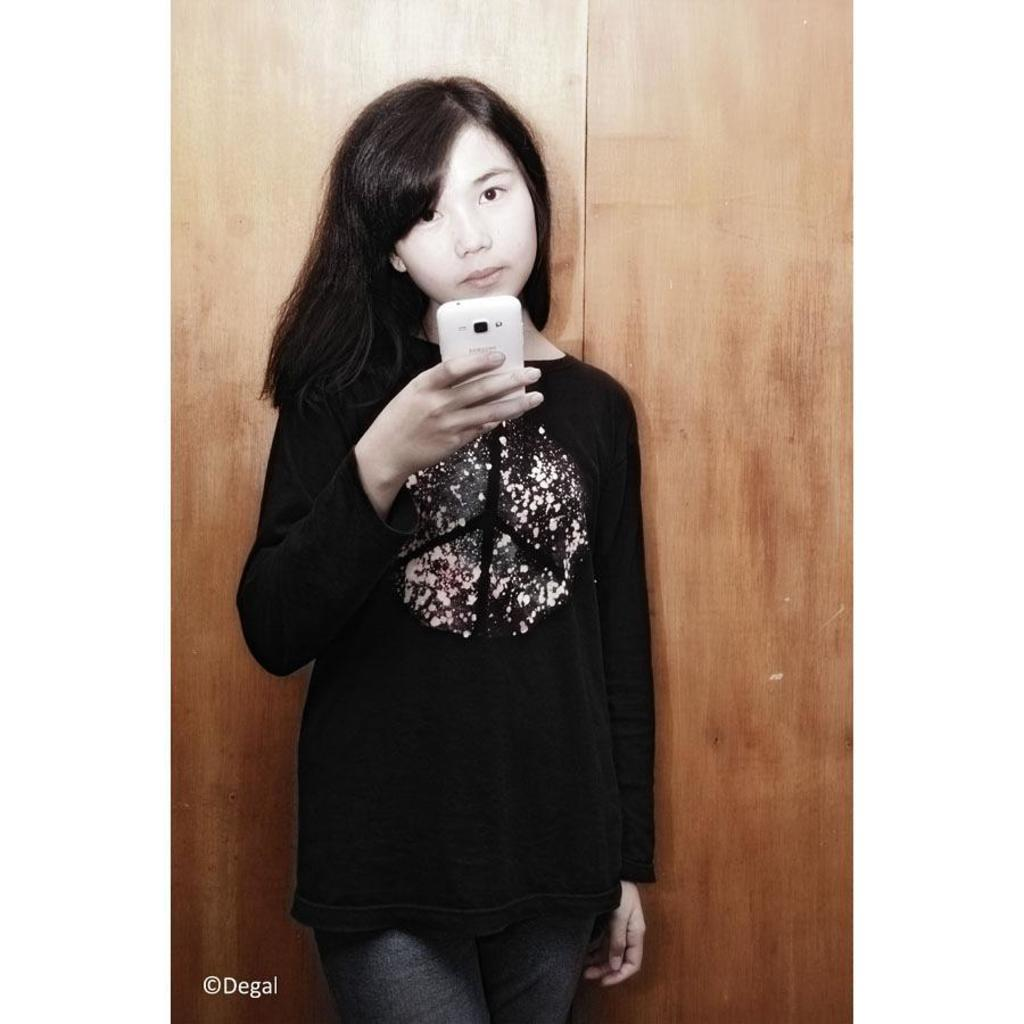Who is the main subject in the picture? There is a girl in the picture. What is the girl doing in the picture? The girl is standing. What object is the girl holding in the picture? The girl is holding a white mobile phone. What is the girl wearing in the picture? The girl is wearing a black dress. What can be seen in the background of the picture? There is a wooden wall in the background of the picture. Where is the group of people sitting on the sofa in the image? There is no group of people sitting on a sofa in the image; it only features a girl standing with a white mobile phone. 